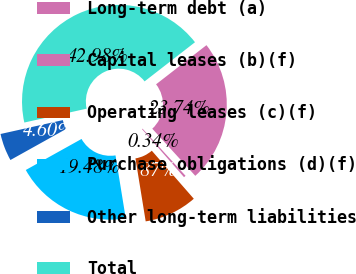Convert chart to OTSL. <chart><loc_0><loc_0><loc_500><loc_500><pie_chart><fcel>Long-term debt (a)<fcel>Capital leases (b)(f)<fcel>Operating leases (c)(f)<fcel>Purchase obligations (d)(f)<fcel>Other long-term liabilities<fcel>Total<nl><fcel>23.74%<fcel>0.34%<fcel>8.87%<fcel>19.48%<fcel>4.6%<fcel>42.98%<nl></chart> 